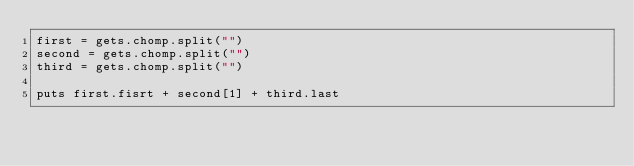<code> <loc_0><loc_0><loc_500><loc_500><_Ruby_>first = gets.chomp.split("")
second = gets.chomp.split("")
third = gets.chomp.split("")

puts first.fisrt + second[1] + third.last</code> 